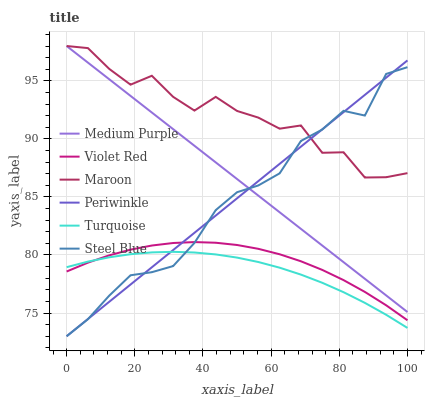Does Maroon have the minimum area under the curve?
Answer yes or no. No. Does Turquoise have the maximum area under the curve?
Answer yes or no. No. Is Turquoise the smoothest?
Answer yes or no. No. Is Turquoise the roughest?
Answer yes or no. No. Does Turquoise have the lowest value?
Answer yes or no. No. Does Turquoise have the highest value?
Answer yes or no. No. Is Violet Red less than Maroon?
Answer yes or no. Yes. Is Medium Purple greater than Violet Red?
Answer yes or no. Yes. Does Violet Red intersect Maroon?
Answer yes or no. No. 